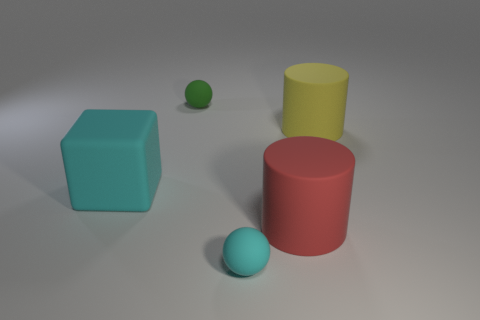What shapes are present in the image? The image shows a variety of shapes: there's a cube, a sphere, and cylinders. Is there a pattern to the arrangement of these objects? The objects seem to be arranged randomly without a discernible pattern. 